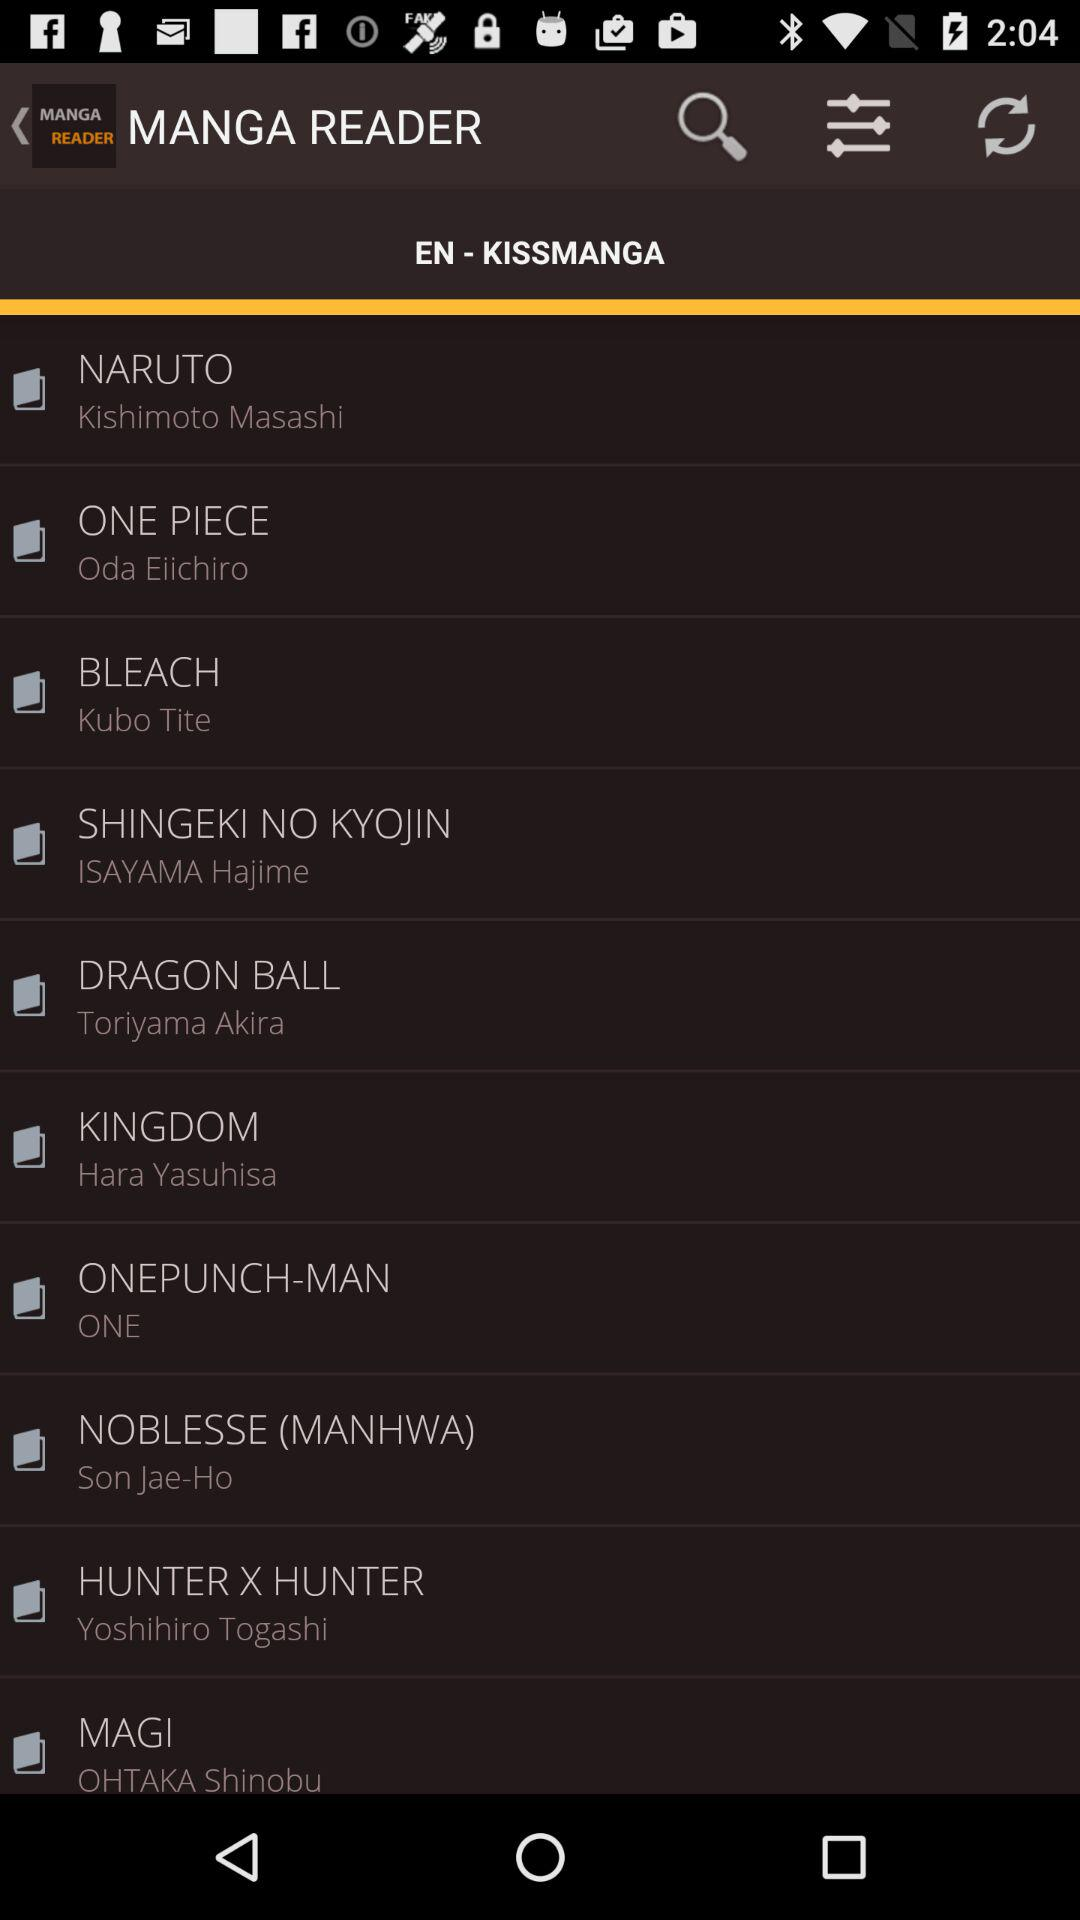What is the name of the article written by Hara Yasuhisa? The name of Hara Yasuhisa's article is "KINGDOM". 